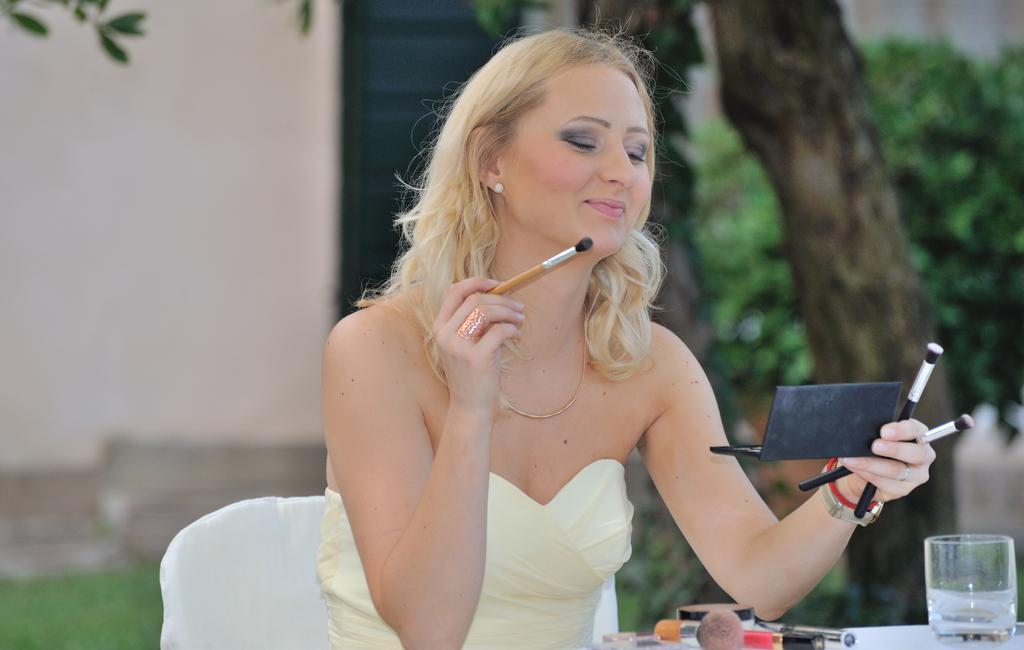In one or two sentences, can you explain what this image depicts? In this image we can see a woman sitting on the chair holding brushes and a box in her hands. In the foreground we can see a group of brushes and a glass placed on the table. In the background we can see a group of trees and building with the door. 